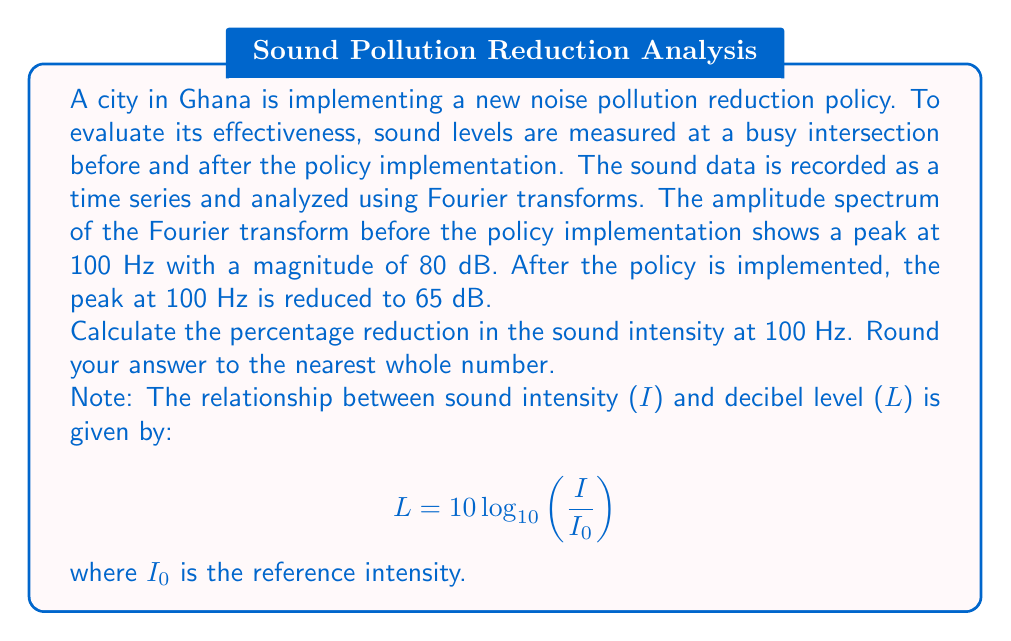Could you help me with this problem? To solve this problem, we'll follow these steps:

1) First, recall that the decibel scale is logarithmic. The formula relating sound intensity ($I$) to decibel level ($L$) is:

   $$L = 10 \log_{10}\left(\frac{I}{I_0}\right)$$

   where $I_0$ is a reference intensity.

2) We're interested in the ratio of intensities before and after the policy implementation. Let's call the initial intensity $I_1$ and the final intensity $I_2$. We can write two equations:

   $$80 = 10 \log_{10}\left(\frac{I_1}{I_0}\right)$$
   $$65 = 10 \log_{10}\left(\frac{I_2}{I_0}\right)$$

3) We can subtract these equations:

   $$80 - 65 = 10 \log_{10}\left(\frac{I_1}{I_0}\right) - 10 \log_{10}\left(\frac{I_2}{I_0}\right)$$

4) Using the logarithm property $\log(a) - \log(b) = \log(a/b)$, we get:

   $$15 = 10 \log_{10}\left(\frac{I_1/I_0}{I_2/I_0}\right) = 10 \log_{10}\left(\frac{I_1}{I_2}\right)$$

5) Now we can solve for $I_1/I_2$:

   $$\frac{15}{10} = \log_{10}\left(\frac{I_1}{I_2}\right)$$
   $$10^{1.5} = \frac{I_1}{I_2}$$
   $$31.6228... = \frac{I_1}{I_2}$$

6) This means that $I_1$ is about 31.6228 times greater than $I_2$. To find the percentage reduction, we calculate:

   Percentage reduction = $\frac{I_1 - I_2}{I_1} \times 100\%$
                        = $\frac{31.6228 - 1}{31.6228} \times 100\%$
                        = $96.84\%$

7) Rounding to the nearest whole number, we get 97%.

This significant reduction demonstrates the effectiveness of the noise pollution reduction policy in decreasing the sound intensity at the frequency of interest.
Answer: 97% 